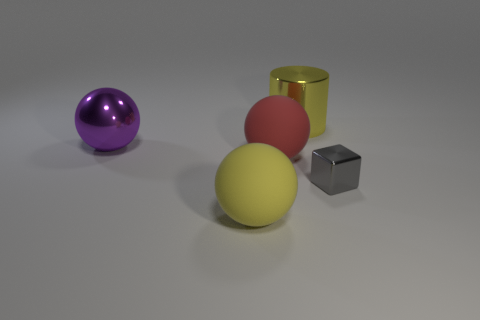What kind of lighting is being used to illuminate these objects? The lighting in the image is soft and diffuse, possibly from a studio light or window out of frame. The shadows are soft-edged, suggesting a single light source with a broad diffusion. 